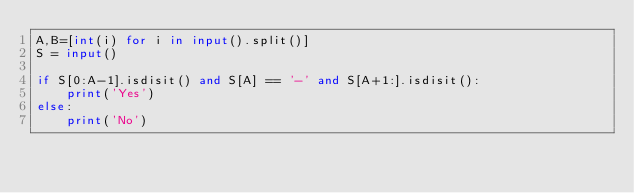Convert code to text. <code><loc_0><loc_0><loc_500><loc_500><_Python_>A,B=[int(i) for i in input().split()]
S = input()

if S[0:A-1].isdisit() and S[A] == '-' and S[A+1:].isdisit():
    print('Yes')
else:
    print('No')</code> 